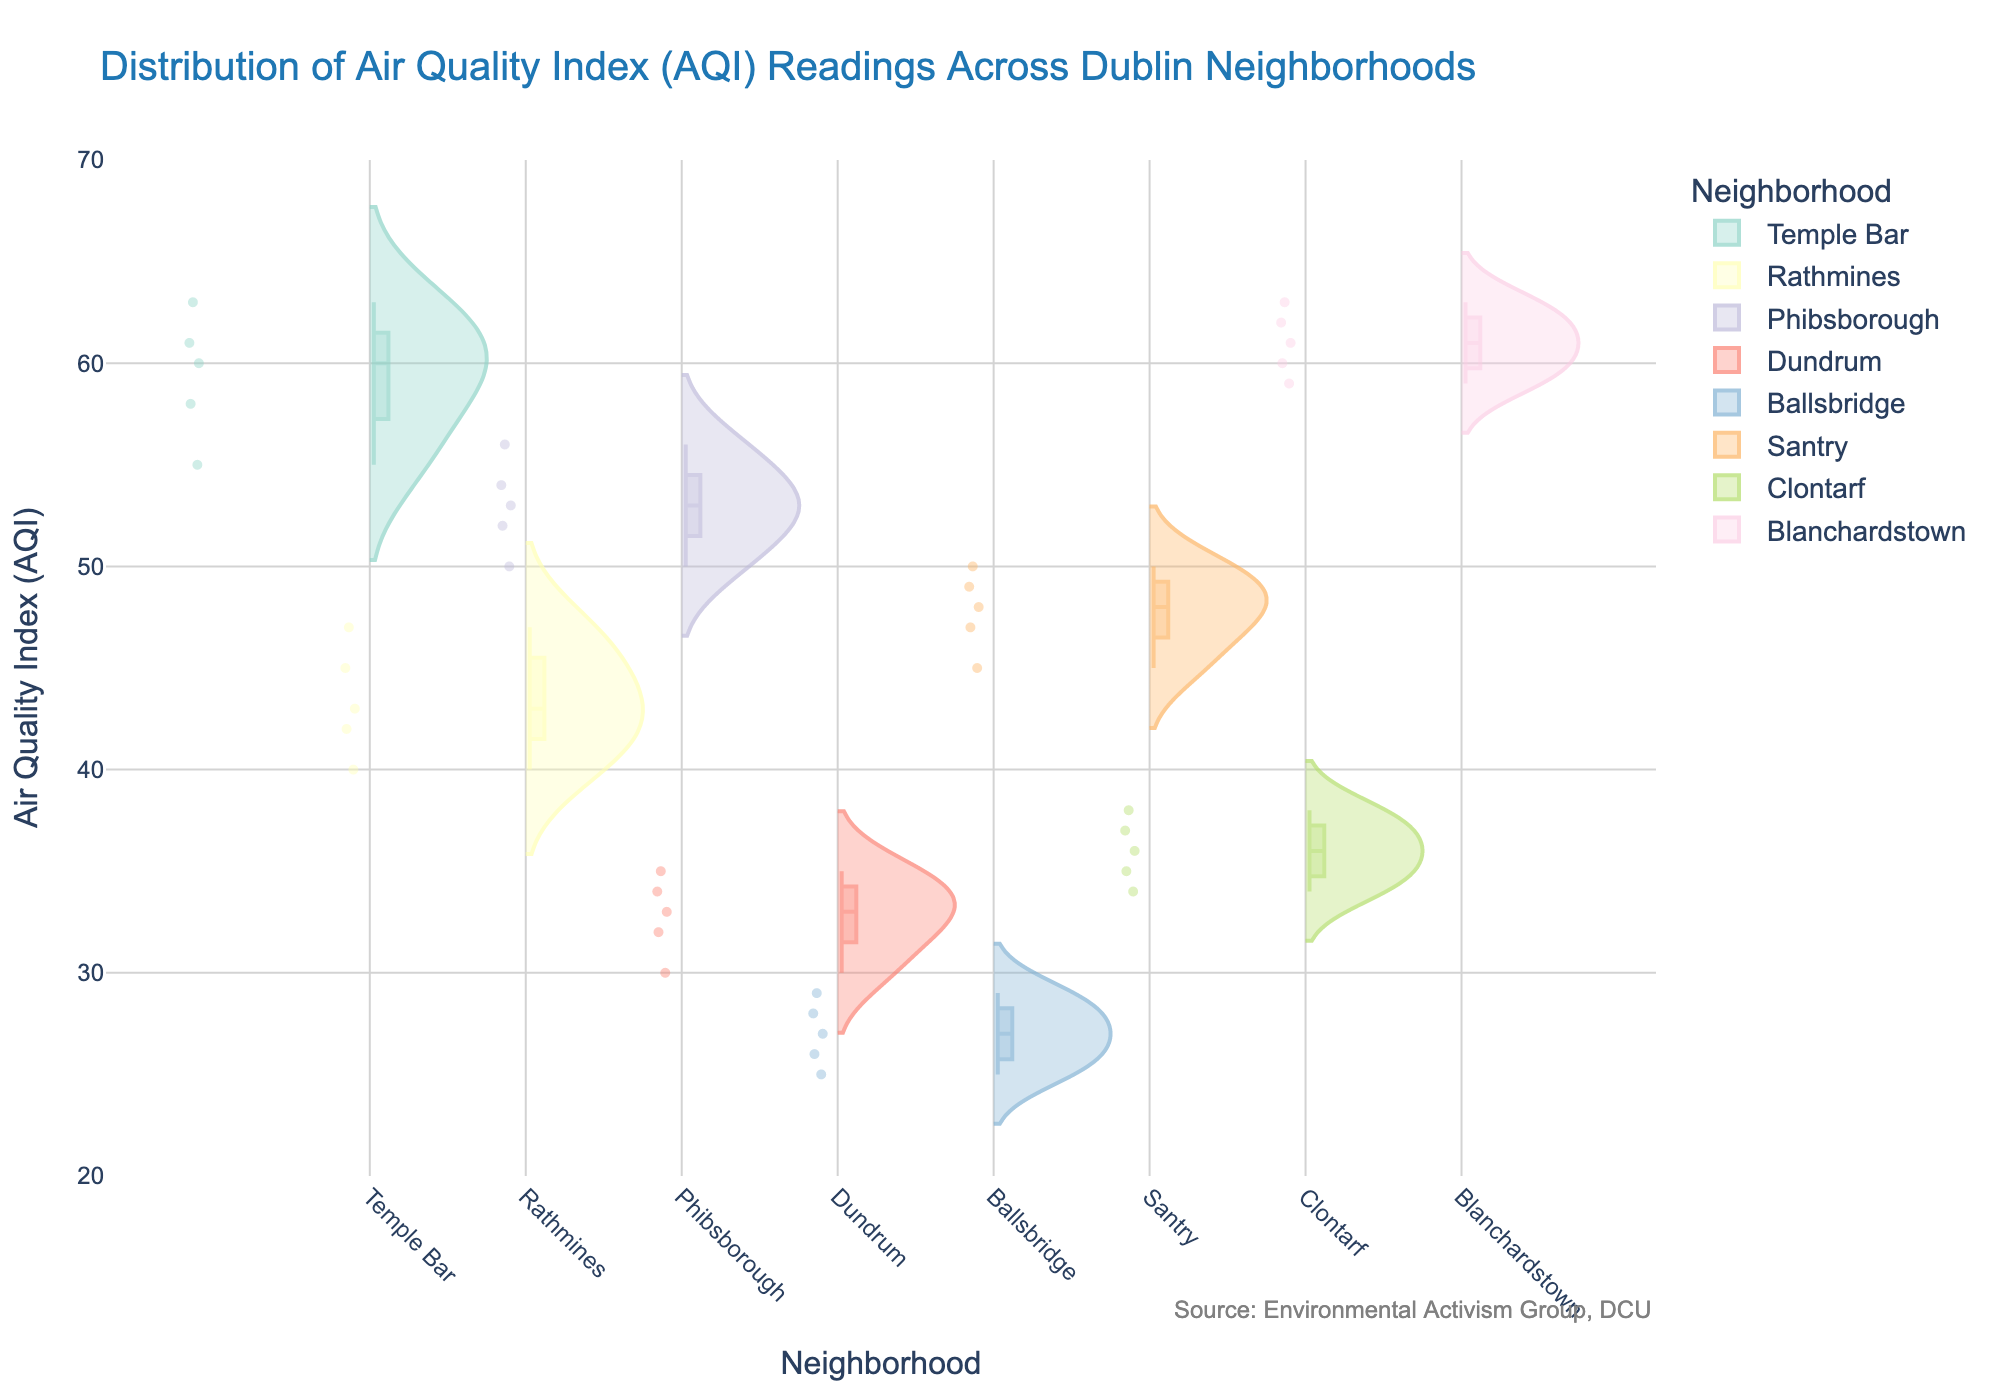What is the title of the figure? The title is usually located at the top of the chart. For this figure, it states the overall purpose or subject of the chart.
Answer: Distribution of Air Quality Index (AQI) Readings Across Dublin Neighborhoods Which neighborhood has the widest range of AQI readings? The width of the range in a violin plot is represented by the spread of the distribution. Look for the neighborhood with the most spread-out distribution.
Answer: Temple Bar What is the highest AQI reading shown in the figure? Identify the top point of any violin in the chart. The highest point across all neighborhoods gives the highest AQI reading.
Answer: 63 Which neighborhood has the lowest median AQI reading? The median is shown by a line inside the box within each violin. Compare the position of these lines across neighborhoods to find the lowest one.
Answer: Ballsbridge Between Phibsborough and Blanchardstown, which neighborhood has a higher median AQI reading? Compare the median lines (horizontal lines within the boxes) of the violins for Phibsborough and Blanchardstown to see which is higher.
Answer: Blanchardstown How many neighborhoods have AQI readings with a median above 50? Count the number of neighborhoods where the median line (horizontal line inside the box) is above the 50 mark on the y-axis.
Answer: 3 Compared to Santry, which neighborhood has a similar range of AQI readings? Look for another neighborhood whose spread or distribution is similar to that of Santry. Both the width and the spread of the violins are key indicators.
Answer: Phibsborough What is the range of AQI readings in Dundrum? The range can be determined by the lowest and highest points of the violin. Observe these values for Dundrum.
Answer: 30 to 35 Which neighborhood has the smallest interquartile range (IQR)? The IQR is represented by the width of the box inside the violin. Look for the neighborhood with the most compact (narrowest) box.
Answer: Dundrum Do any neighborhoods have overlapping distributions? Overlapping distributions would mean that the violins for different neighborhoods are visually overlapping each other on the plot. Observe the violins for any such overlaps.
Answer: Yes 